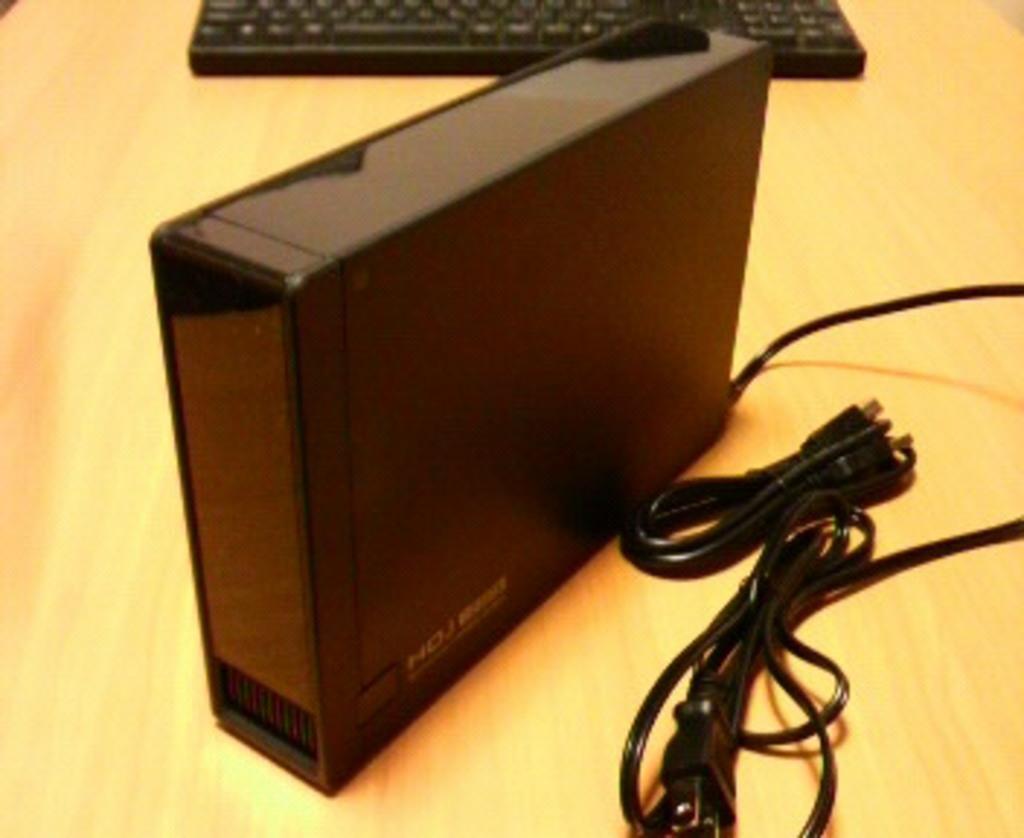Please provide a concise description of this image. This is a zoomed in picture. In the foreground there is a wooden table on the top of which a box and a keyboard is placed and we can see the cables are placed on the top of the table. 